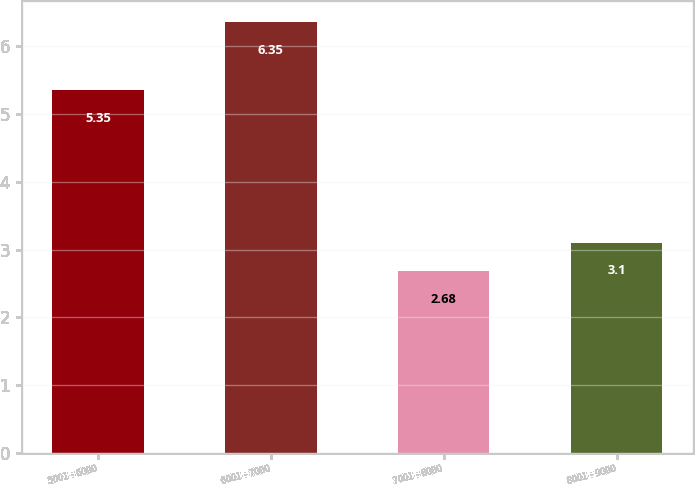Convert chart to OTSL. <chart><loc_0><loc_0><loc_500><loc_500><bar_chart><fcel>5001 - 6000<fcel>6001 - 7000<fcel>7001 - 8000<fcel>8001 - 9000<nl><fcel>5.35<fcel>6.35<fcel>2.68<fcel>3.1<nl></chart> 